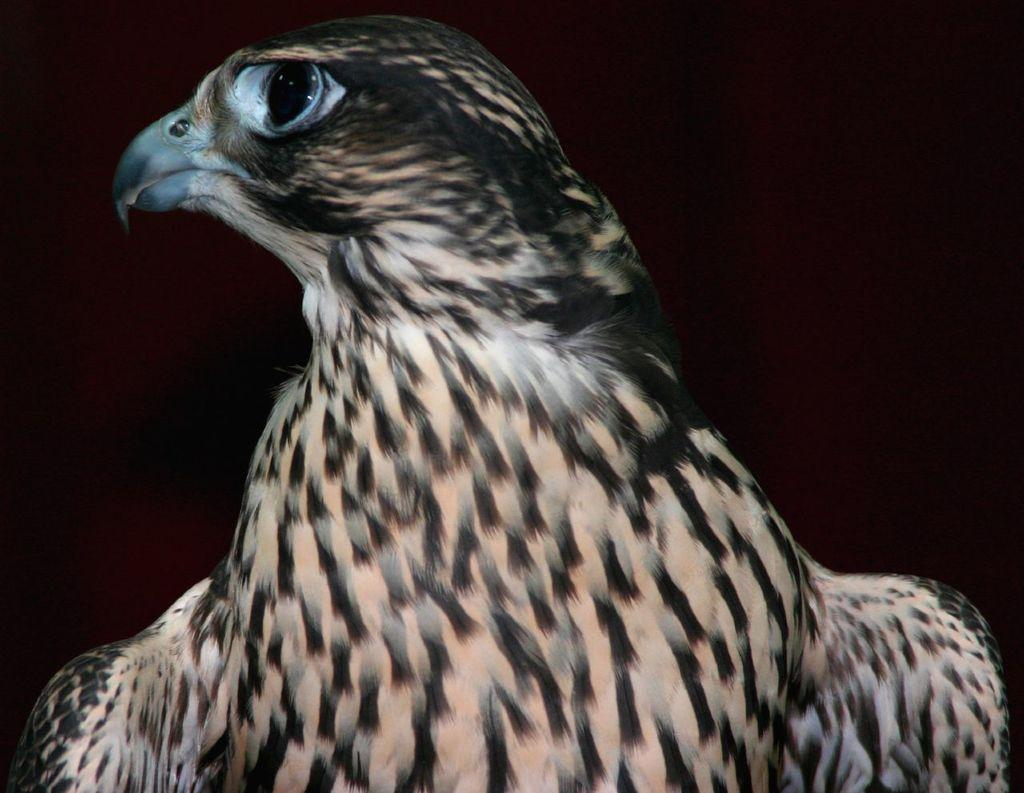What is the color scheme of the background in the image? The background of the image is dark. What is the main subject in the middle of the image? There is an eagle in the middle of the image. What type of trip can be seen in the image? There is no trip present in the image; it features an eagle. What is the eagle holding in its grip in the image? The image does not show the eagle holding anything in its grip. 